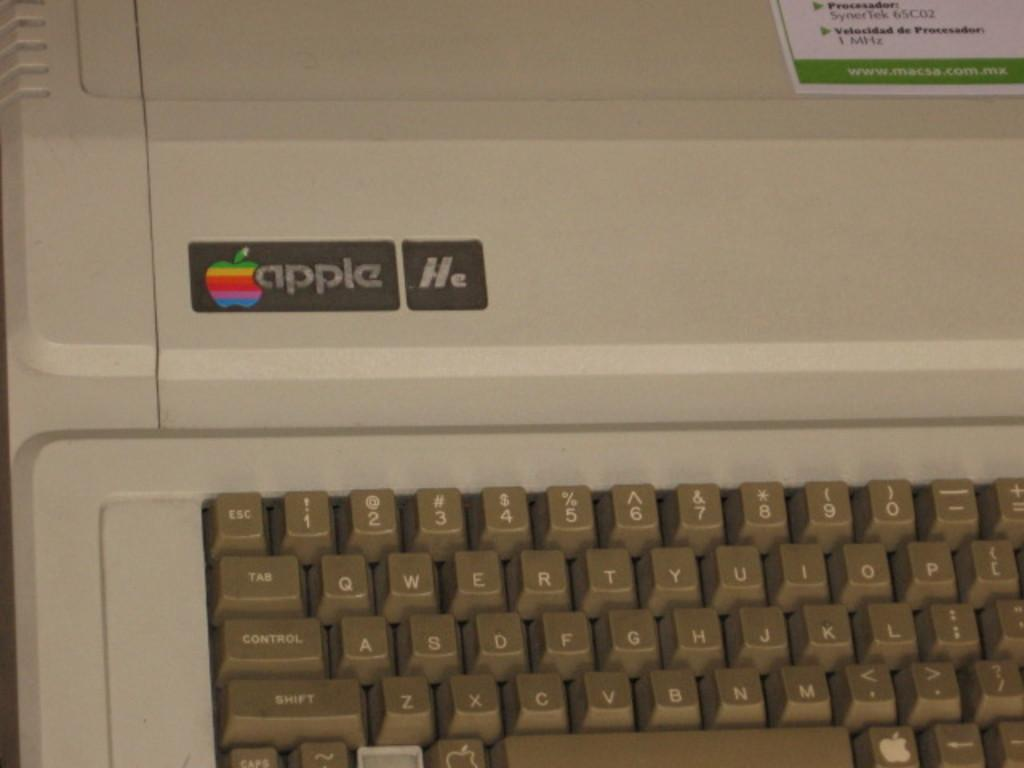<image>
Write a terse but informative summary of the picture. An old Apple IIe computer keyboard that is beige 